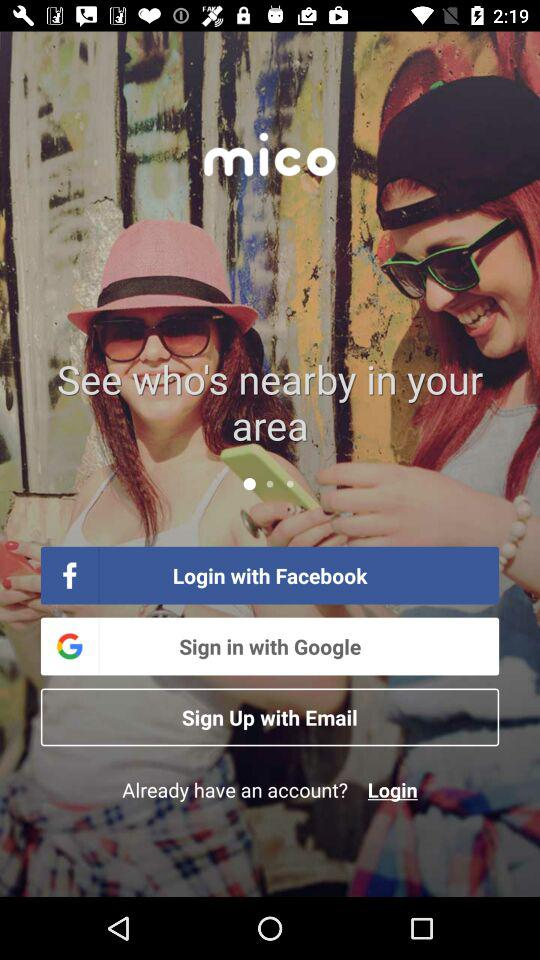What is the name of the application? The name of the application is "mico". 